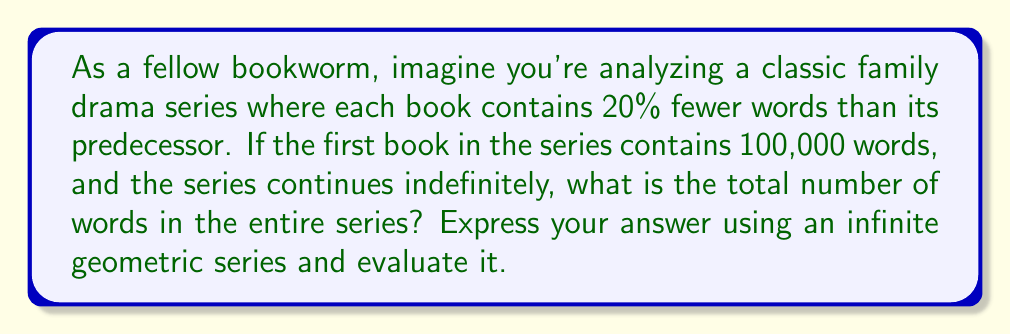What is the answer to this math problem? Let's approach this step-by-step:

1) First, we need to identify the terms of our geometric series:
   - First term (a): 100,000 words
   - Common ratio (r): 0.8 (each book has 80% of the words of the previous one)

2) The infinite geometric series formula is:

   $$S_{\infty} = \frac{a}{1-r}$$

   Where $S_{\infty}$ is the sum of the infinite series, $a$ is the first term, and $r$ is the common ratio.

3) We know:
   $a = 100,000$
   $r = 0.8$

4) Let's substitute these values into our formula:

   $$S_{\infty} = \frac{100,000}{1-0.8}$$

5) Simplify:
   $$S_{\infty} = \frac{100,000}{0.2}$$

6) Calculate:
   $$S_{\infty} = 500,000$$

Therefore, the total number of words in the entire infinite series is 500,000.
Answer: 500,000 words 